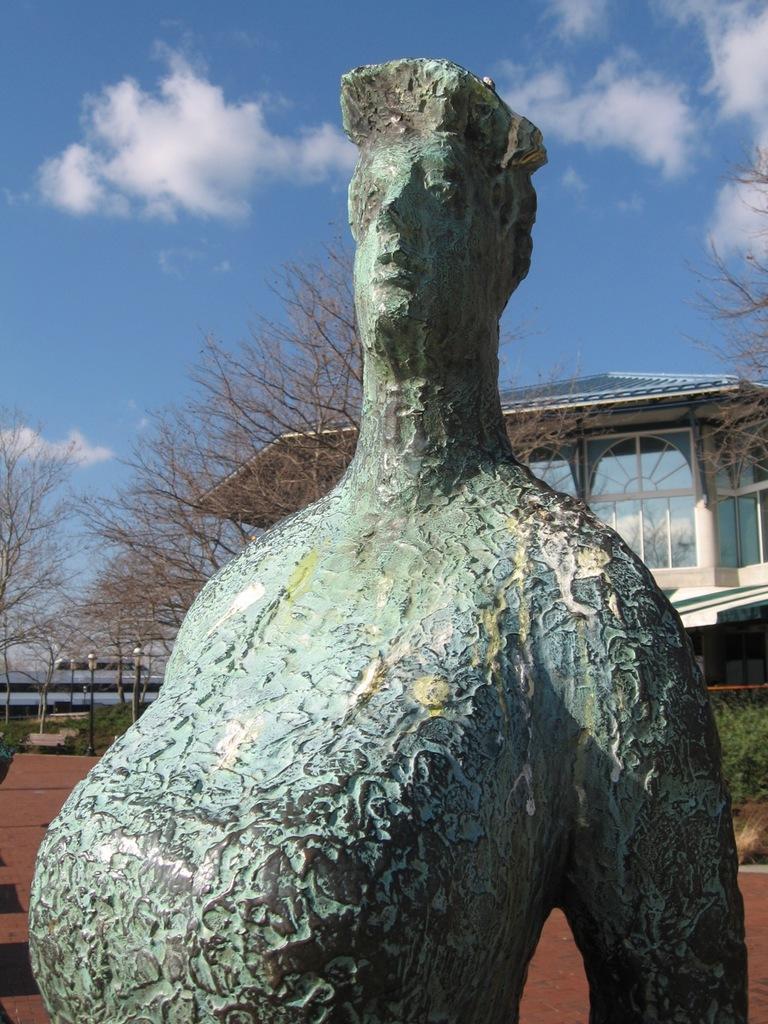Describe this image in one or two sentences. In the picture I can see a statue of a person. In the background I can see trees, a buildings, pole lights, the sky and some other objects. 